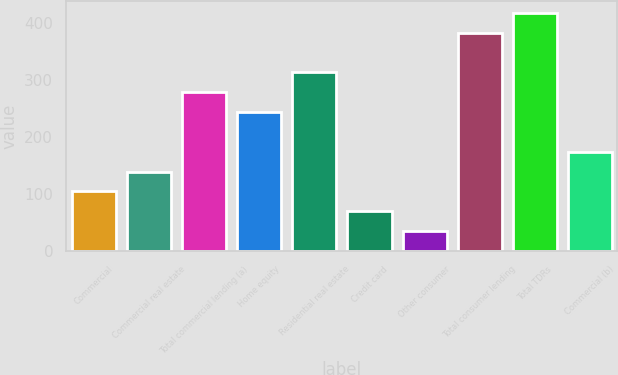<chart> <loc_0><loc_0><loc_500><loc_500><bar_chart><fcel>Commercial<fcel>Commercial real estate<fcel>Total commercial lending (a)<fcel>Home equity<fcel>Residential real estate<fcel>Credit card<fcel>Other consumer<fcel>Total consumer lending<fcel>Total TDRs<fcel>Commercial (b)<nl><fcel>105.1<fcel>139.8<fcel>278.6<fcel>243.9<fcel>313.3<fcel>70.4<fcel>35.7<fcel>382.7<fcel>417.4<fcel>174.5<nl></chart> 